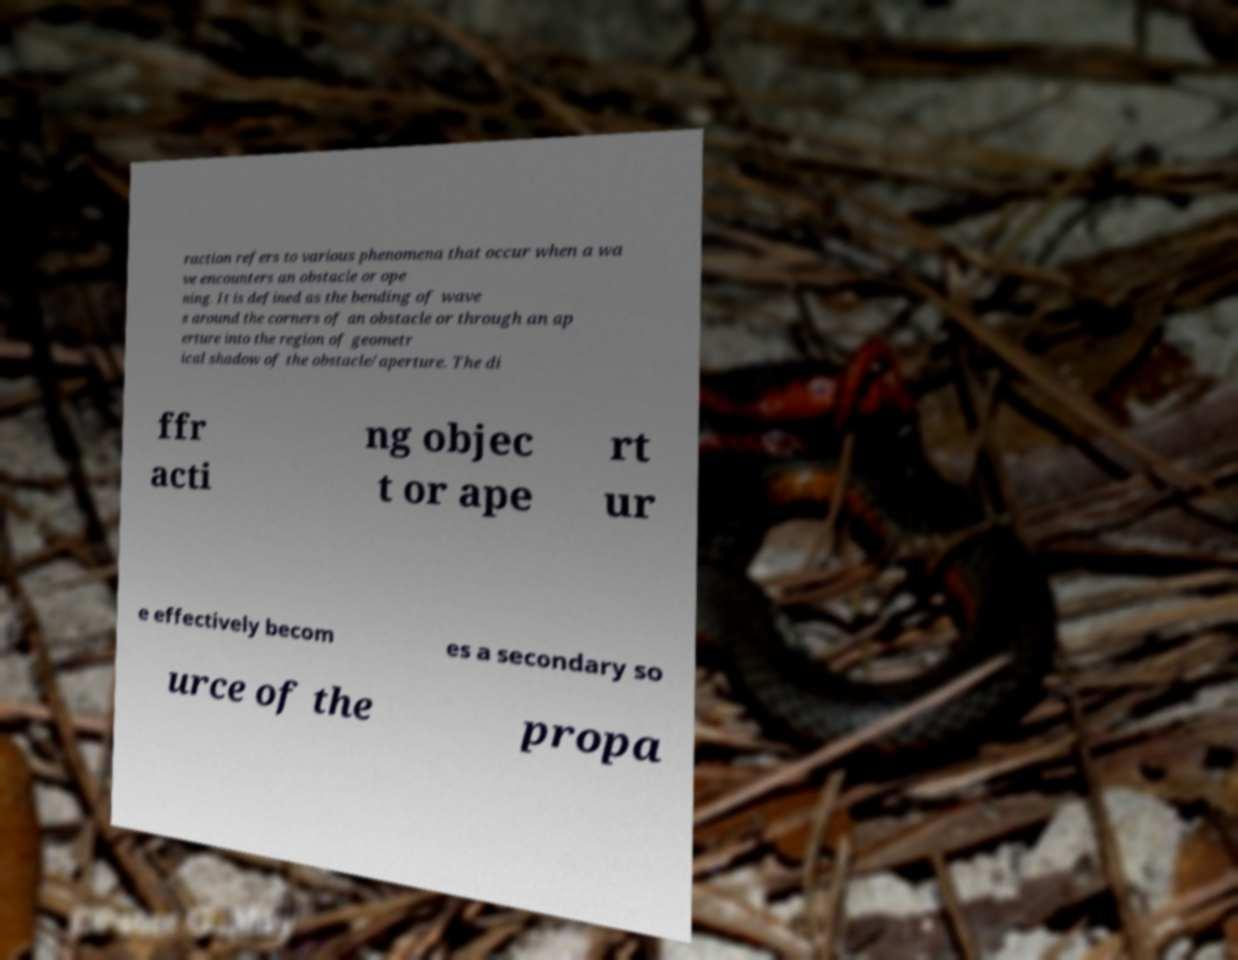Could you extract and type out the text from this image? raction refers to various phenomena that occur when a wa ve encounters an obstacle or ope ning. It is defined as the bending of wave s around the corners of an obstacle or through an ap erture into the region of geometr ical shadow of the obstacle/aperture. The di ffr acti ng objec t or ape rt ur e effectively becom es a secondary so urce of the propa 